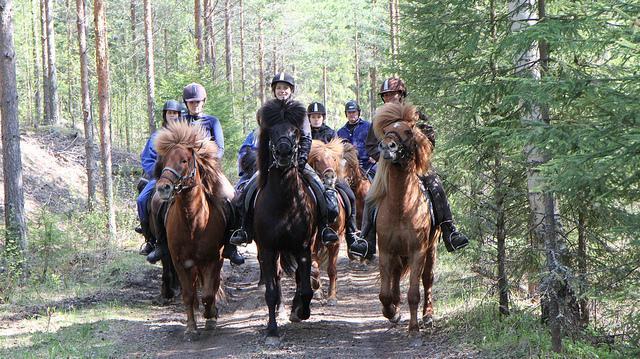How many horses can you see?
Give a very brief answer. 4. How many people can you see?
Give a very brief answer. 2. 